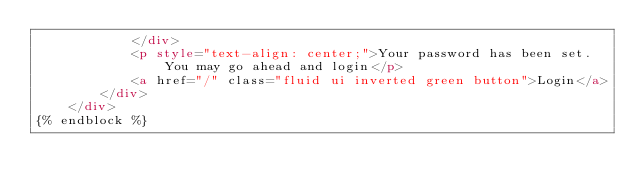Convert code to text. <code><loc_0><loc_0><loc_500><loc_500><_HTML_>            </div> 
            <p style="text-align: center;">Your password has been set. You may go ahead and login</p>
            <a href="/" class="fluid ui inverted green button">Login</a>
        </div>
    </div>
{% endblock %}</code> 